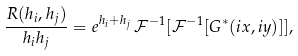Convert formula to latex. <formula><loc_0><loc_0><loc_500><loc_500>\frac { R ( h _ { i } , h _ { j } ) } { h _ { i } h _ { j } } = e ^ { h _ { i } + h _ { j } } \, \mathcal { F } ^ { - 1 } [ \mathcal { F } ^ { - 1 } [ G ^ { * } ( i x , i y ) ] ] ,</formula> 